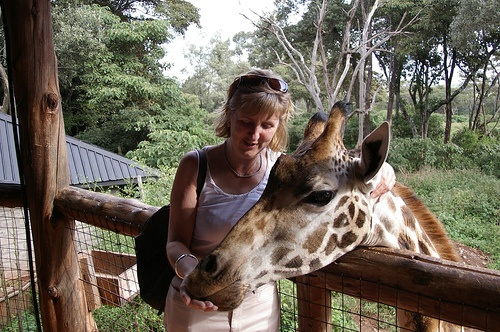Describe the objects in this image and their specific colors. I can see giraffe in black, lightgray, and gray tones, people in black, maroon, gray, and lightgray tones, and handbag in black, maroon, gray, and darkgray tones in this image. 